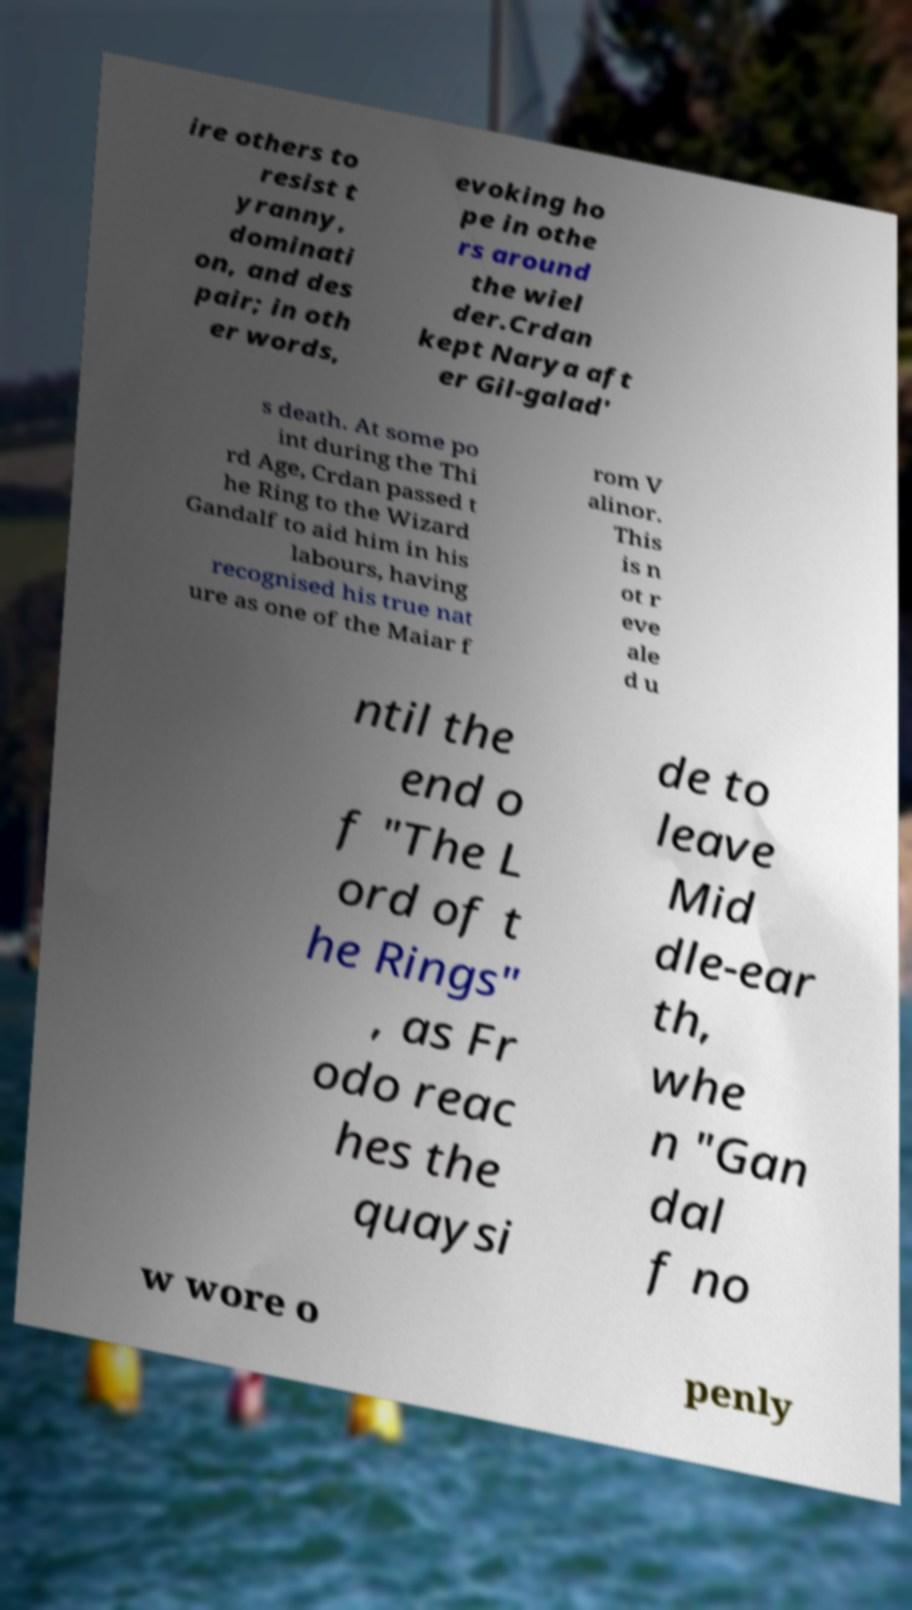Can you accurately transcribe the text from the provided image for me? ire others to resist t yranny, dominati on, and des pair; in oth er words, evoking ho pe in othe rs around the wiel der.Crdan kept Narya aft er Gil-galad' s death. At some po int during the Thi rd Age, Crdan passed t he Ring to the Wizard Gandalf to aid him in his labours, having recognised his true nat ure as one of the Maiar f rom V alinor. This is n ot r eve ale d u ntil the end o f "The L ord of t he Rings" , as Fr odo reac hes the quaysi de to leave Mid dle-ear th, whe n "Gan dal f no w wore o penly 